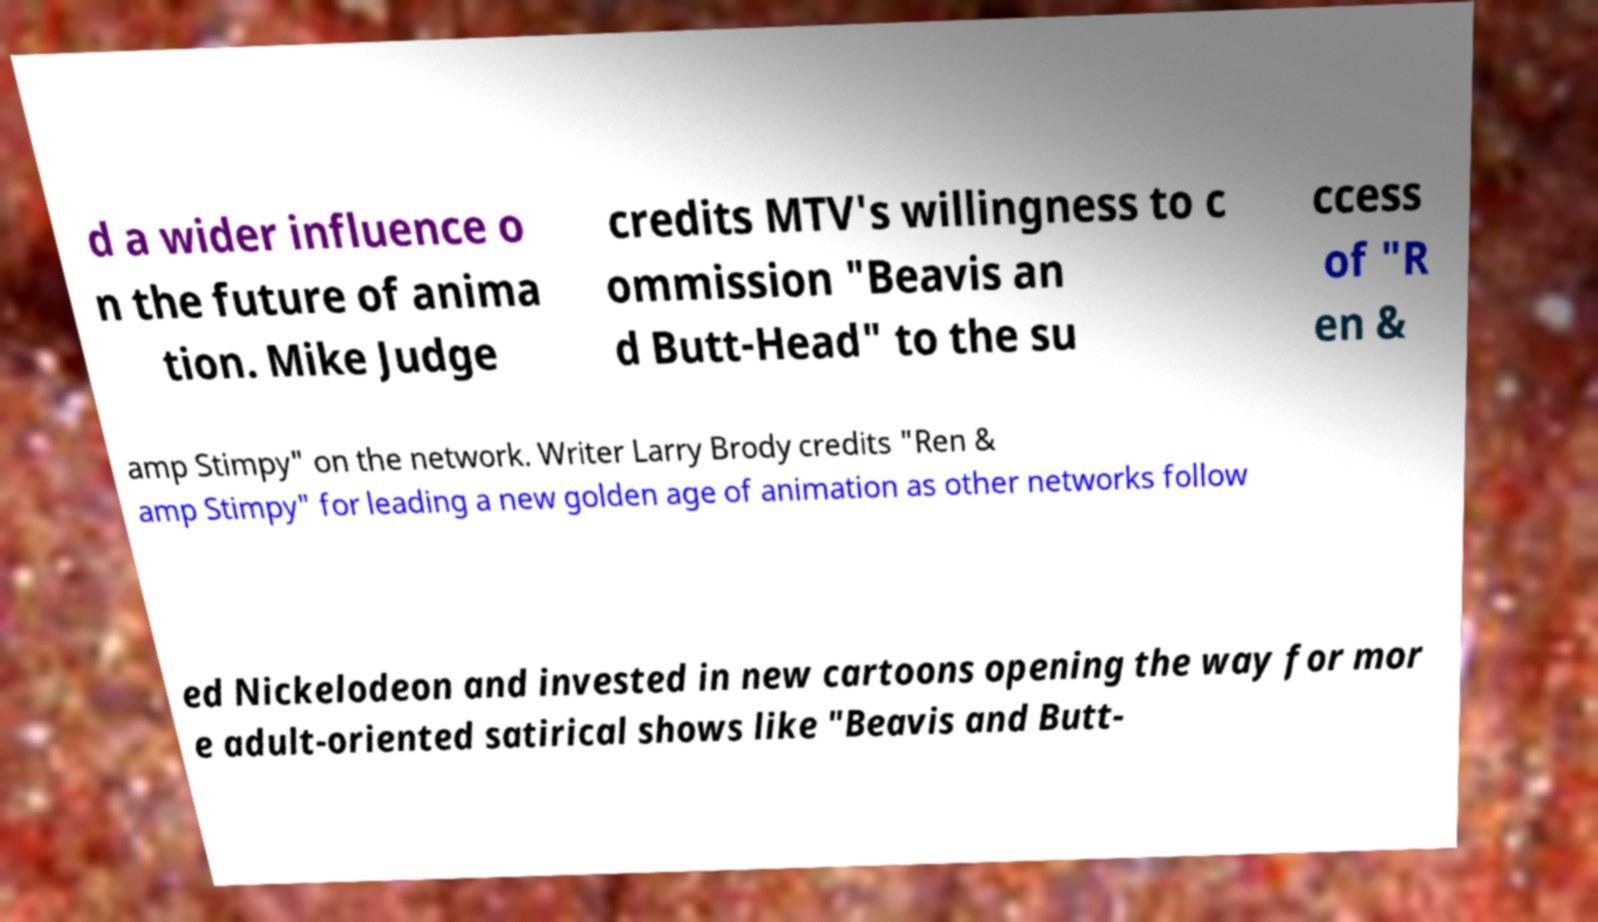There's text embedded in this image that I need extracted. Can you transcribe it verbatim? d a wider influence o n the future of anima tion. Mike Judge credits MTV's willingness to c ommission "Beavis an d Butt-Head" to the su ccess of "R en & amp Stimpy" on the network. Writer Larry Brody credits "Ren & amp Stimpy" for leading a new golden age of animation as other networks follow ed Nickelodeon and invested in new cartoons opening the way for mor e adult-oriented satirical shows like "Beavis and Butt- 